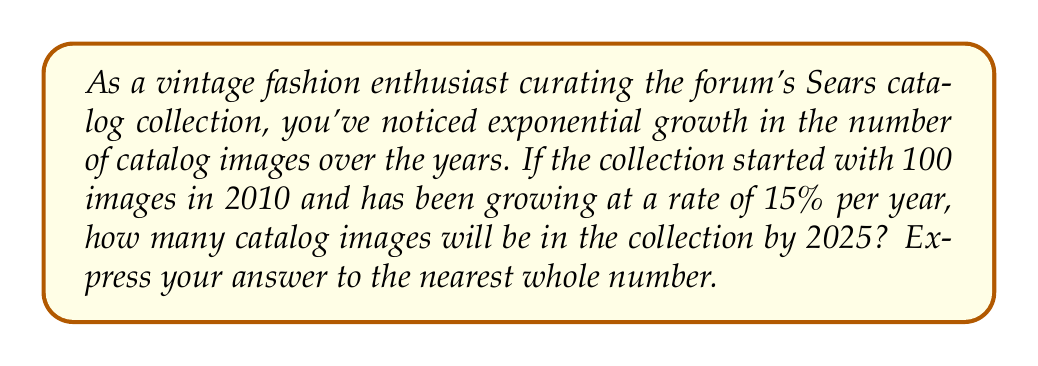Can you answer this question? To solve this problem, we'll use the exponential growth formula:

$$A = P(1 + r)^t$$

Where:
$A$ = Final amount
$P$ = Initial principal (starting amount)
$r$ = Annual growth rate (as a decimal)
$t$ = Time in years

Given:
$P = 100$ (initial number of images in 2010)
$r = 0.15$ (15% annual growth rate)
$t = 15$ (number of years from 2010 to 2025)

Let's substitute these values into the formula:

$$A = 100(1 + 0.15)^{15}$$

Now, let's calculate:

$$\begin{align}
A &= 100(1.15)^{15} \\
&= 100 \cdot 8.13704205352751 \\
&= 813.704205352751
\end{align}$$

Rounding to the nearest whole number:

$$A \approx 814$$

Therefore, by 2025, the Sears catalog collection will contain approximately 814 images.
Answer: 814 images 